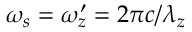<formula> <loc_0><loc_0><loc_500><loc_500>\omega _ { s } = \omega _ { z } ^ { \prime } = 2 \pi c / \lambda _ { z }</formula> 